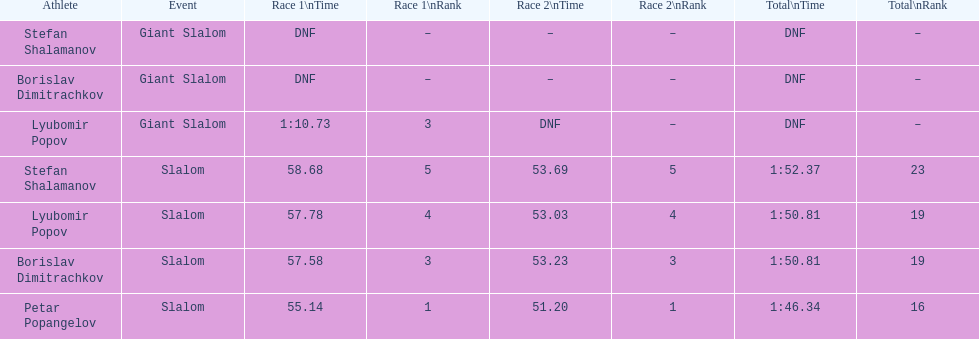What's the overall count of athletes? 4. 